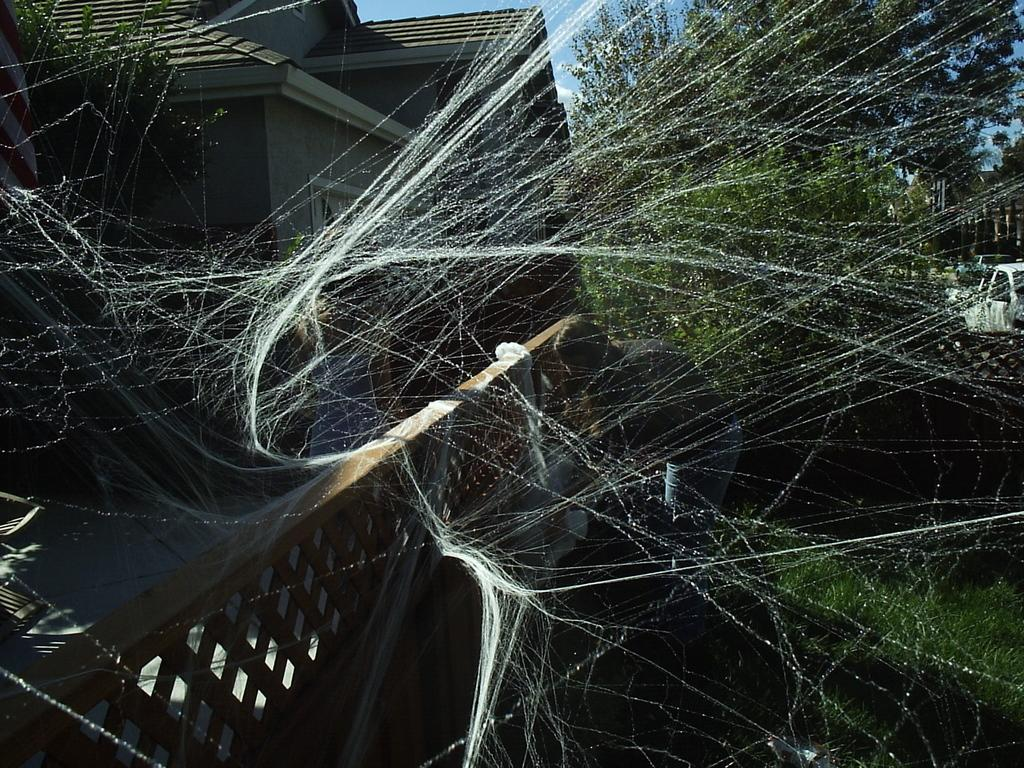What structure is located on the left side of the image? There is a house on the left side of the image. What is present at the bottom of the left side of the image? There is a wooden fence on the left side bottom of the image. What can be seen on the wooden fence? There is a spider web on the wooden fence. What type of vegetation is visible in the background of the image? There are trees in the background of the image. Can you tell me how many loaves of bread are on the spider web? There are no loaves of bread present in the image; it features a spider web on a wooden fence. What type of station is visible in the background of the image? There is no station visible in the background of the image; it features trees. 